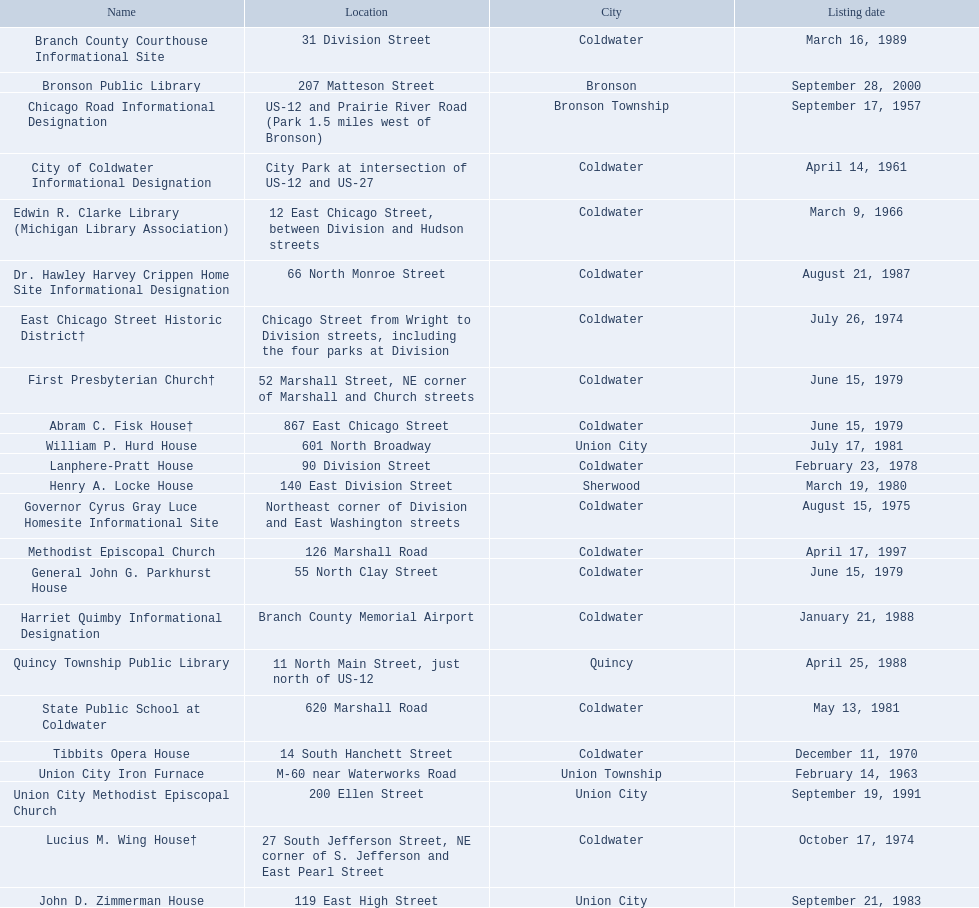In branch county, michigan, which historic sites are located near or on a highway? Chicago Road Informational Designation, City of Coldwater Informational Designation, Quincy Township Public Library, Union City Iron Furnace. From these sites, which are close to only us highways? Chicago Road Informational Designation, City of Coldwater Informational Designation, Quincy Township Public Library. Which historical landmarks in branch county are not buildings and are situated near just us highways? Chicago Road Informational Designation, City of Coldwater Informational Designation. Which non-building historical landmarks near a us highway in branch county are nearest to bronson? Chicago Road Informational Designation. 